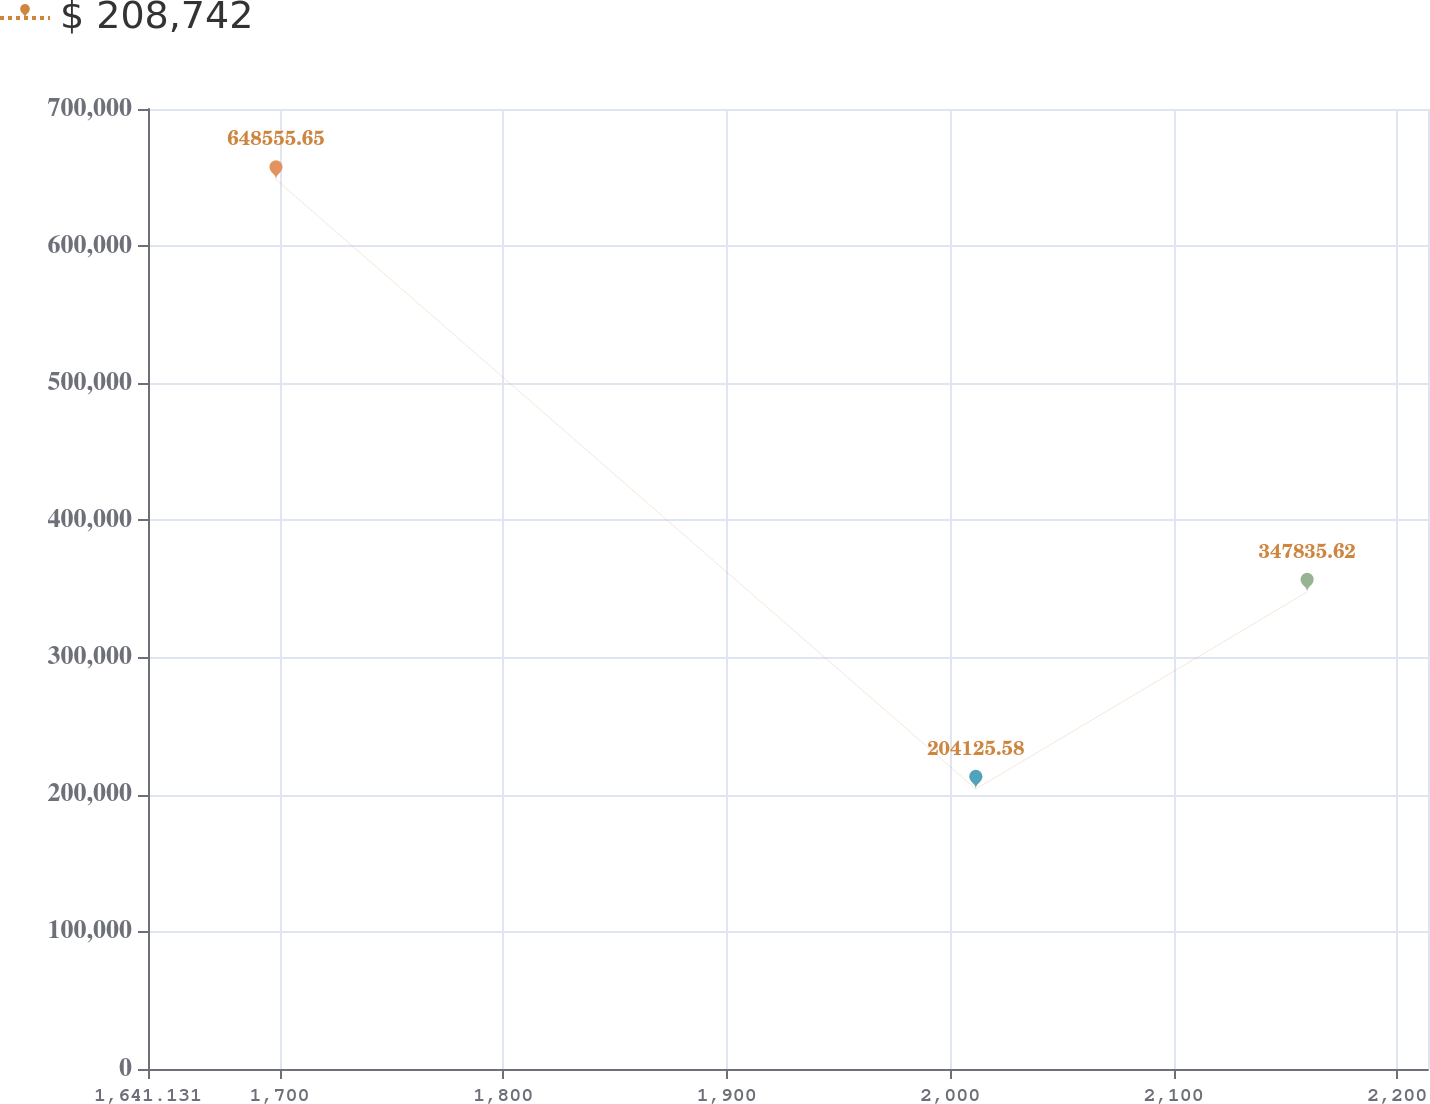Convert chart. <chart><loc_0><loc_0><loc_500><loc_500><line_chart><ecel><fcel>$ 208,742<nl><fcel>1698.39<fcel>648556<nl><fcel>2011.45<fcel>204126<nl><fcel>2159.66<fcel>347836<nl><fcel>2270.98<fcel>826606<nl></chart> 